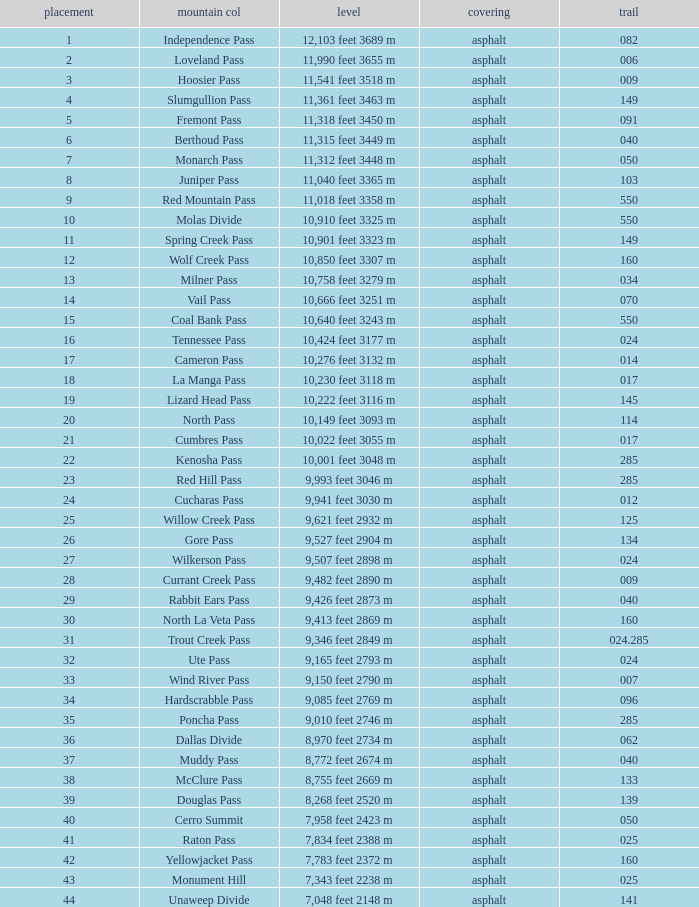Can you parse all the data within this table? {'header': ['placement', 'mountain col', 'level', 'covering', 'trail'], 'rows': [['1', 'Independence Pass', '12,103 feet 3689 m', 'asphalt', '082'], ['2', 'Loveland Pass', '11,990 feet 3655 m', 'asphalt', '006'], ['3', 'Hoosier Pass', '11,541 feet 3518 m', 'asphalt', '009'], ['4', 'Slumgullion Pass', '11,361 feet 3463 m', 'asphalt', '149'], ['5', 'Fremont Pass', '11,318 feet 3450 m', 'asphalt', '091'], ['6', 'Berthoud Pass', '11,315 feet 3449 m', 'asphalt', '040'], ['7', 'Monarch Pass', '11,312 feet 3448 m', 'asphalt', '050'], ['8', 'Juniper Pass', '11,040 feet 3365 m', 'asphalt', '103'], ['9', 'Red Mountain Pass', '11,018 feet 3358 m', 'asphalt', '550'], ['10', 'Molas Divide', '10,910 feet 3325 m', 'asphalt', '550'], ['11', 'Spring Creek Pass', '10,901 feet 3323 m', 'asphalt', '149'], ['12', 'Wolf Creek Pass', '10,850 feet 3307 m', 'asphalt', '160'], ['13', 'Milner Pass', '10,758 feet 3279 m', 'asphalt', '034'], ['14', 'Vail Pass', '10,666 feet 3251 m', 'asphalt', '070'], ['15', 'Coal Bank Pass', '10,640 feet 3243 m', 'asphalt', '550'], ['16', 'Tennessee Pass', '10,424 feet 3177 m', 'asphalt', '024'], ['17', 'Cameron Pass', '10,276 feet 3132 m', 'asphalt', '014'], ['18', 'La Manga Pass', '10,230 feet 3118 m', 'asphalt', '017'], ['19', 'Lizard Head Pass', '10,222 feet 3116 m', 'asphalt', '145'], ['20', 'North Pass', '10,149 feet 3093 m', 'asphalt', '114'], ['21', 'Cumbres Pass', '10,022 feet 3055 m', 'asphalt', '017'], ['22', 'Kenosha Pass', '10,001 feet 3048 m', 'asphalt', '285'], ['23', 'Red Hill Pass', '9,993 feet 3046 m', 'asphalt', '285'], ['24', 'Cucharas Pass', '9,941 feet 3030 m', 'asphalt', '012'], ['25', 'Willow Creek Pass', '9,621 feet 2932 m', 'asphalt', '125'], ['26', 'Gore Pass', '9,527 feet 2904 m', 'asphalt', '134'], ['27', 'Wilkerson Pass', '9,507 feet 2898 m', 'asphalt', '024'], ['28', 'Currant Creek Pass', '9,482 feet 2890 m', 'asphalt', '009'], ['29', 'Rabbit Ears Pass', '9,426 feet 2873 m', 'asphalt', '040'], ['30', 'North La Veta Pass', '9,413 feet 2869 m', 'asphalt', '160'], ['31', 'Trout Creek Pass', '9,346 feet 2849 m', 'asphalt', '024.285'], ['32', 'Ute Pass', '9,165 feet 2793 m', 'asphalt', '024'], ['33', 'Wind River Pass', '9,150 feet 2790 m', 'asphalt', '007'], ['34', 'Hardscrabble Pass', '9,085 feet 2769 m', 'asphalt', '096'], ['35', 'Poncha Pass', '9,010 feet 2746 m', 'asphalt', '285'], ['36', 'Dallas Divide', '8,970 feet 2734 m', 'asphalt', '062'], ['37', 'Muddy Pass', '8,772 feet 2674 m', 'asphalt', '040'], ['38', 'McClure Pass', '8,755 feet 2669 m', 'asphalt', '133'], ['39', 'Douglas Pass', '8,268 feet 2520 m', 'asphalt', '139'], ['40', 'Cerro Summit', '7,958 feet 2423 m', 'asphalt', '050'], ['41', 'Raton Pass', '7,834 feet 2388 m', 'asphalt', '025'], ['42', 'Yellowjacket Pass', '7,783 feet 2372 m', 'asphalt', '160'], ['43', 'Monument Hill', '7,343 feet 2238 m', 'asphalt', '025'], ['44', 'Unaweep Divide', '7,048 feet 2148 m', 'asphalt', '141']]} What is the Mountain Pass with a 21 Rank? Cumbres Pass. 